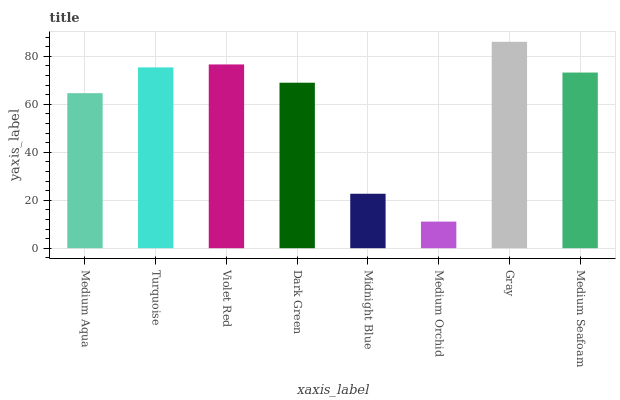Is Medium Orchid the minimum?
Answer yes or no. Yes. Is Gray the maximum?
Answer yes or no. Yes. Is Turquoise the minimum?
Answer yes or no. No. Is Turquoise the maximum?
Answer yes or no. No. Is Turquoise greater than Medium Aqua?
Answer yes or no. Yes. Is Medium Aqua less than Turquoise?
Answer yes or no. Yes. Is Medium Aqua greater than Turquoise?
Answer yes or no. No. Is Turquoise less than Medium Aqua?
Answer yes or no. No. Is Medium Seafoam the high median?
Answer yes or no. Yes. Is Dark Green the low median?
Answer yes or no. Yes. Is Turquoise the high median?
Answer yes or no. No. Is Gray the low median?
Answer yes or no. No. 